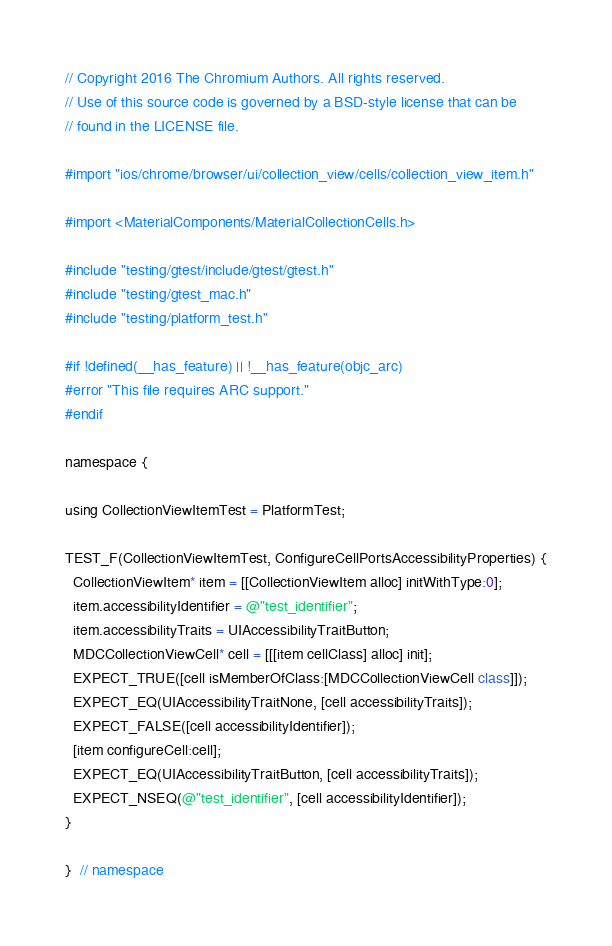<code> <loc_0><loc_0><loc_500><loc_500><_ObjectiveC_>// Copyright 2016 The Chromium Authors. All rights reserved.
// Use of this source code is governed by a BSD-style license that can be
// found in the LICENSE file.

#import "ios/chrome/browser/ui/collection_view/cells/collection_view_item.h"

#import <MaterialComponents/MaterialCollectionCells.h>

#include "testing/gtest/include/gtest/gtest.h"
#include "testing/gtest_mac.h"
#include "testing/platform_test.h"

#if !defined(__has_feature) || !__has_feature(objc_arc)
#error "This file requires ARC support."
#endif

namespace {

using CollectionViewItemTest = PlatformTest;

TEST_F(CollectionViewItemTest, ConfigureCellPortsAccessibilityProperties) {
  CollectionViewItem* item = [[CollectionViewItem alloc] initWithType:0];
  item.accessibilityIdentifier = @"test_identifier";
  item.accessibilityTraits = UIAccessibilityTraitButton;
  MDCCollectionViewCell* cell = [[[item cellClass] alloc] init];
  EXPECT_TRUE([cell isMemberOfClass:[MDCCollectionViewCell class]]);
  EXPECT_EQ(UIAccessibilityTraitNone, [cell accessibilityTraits]);
  EXPECT_FALSE([cell accessibilityIdentifier]);
  [item configureCell:cell];
  EXPECT_EQ(UIAccessibilityTraitButton, [cell accessibilityTraits]);
  EXPECT_NSEQ(@"test_identifier", [cell accessibilityIdentifier]);
}

}  // namespace
</code> 